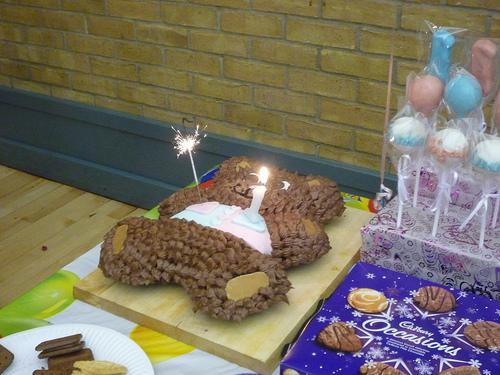Question: what is on the left of the cake?
Choices:
A. A sparkler.
B. A candle.
C. A plate.
D. A bowl of fruit.
Answer with the letter. Answer: A Question: when will the sparkler stop?
Choices:
A. When it starts to rain.
B. When it's burned out.
C. When someone snuffs it out.
D. When it's waved in the air.
Answer with the letter. Answer: B Question: what shape is the cake?
Choices:
A. A bear.
B. A dog.
C. A cat.
D. A cow.
Answer with the letter. Answer: A Question: what company is on the blue box?
Choices:
A. Tiffany's.
B. Cadbury.
C. Best Buy.
D. Nike.
Answer with the letter. Answer: B Question: what is on the plate to the left?
Choices:
A. Cupcakes.
B. Candy.
C. Cookies.
D. Fruit.
Answer with the letter. Answer: C Question: where is the candle?
Choices:
A. On the table.
B. On the cake.
C. In the trashcan.
D. On the cupcake.
Answer with the letter. Answer: B 